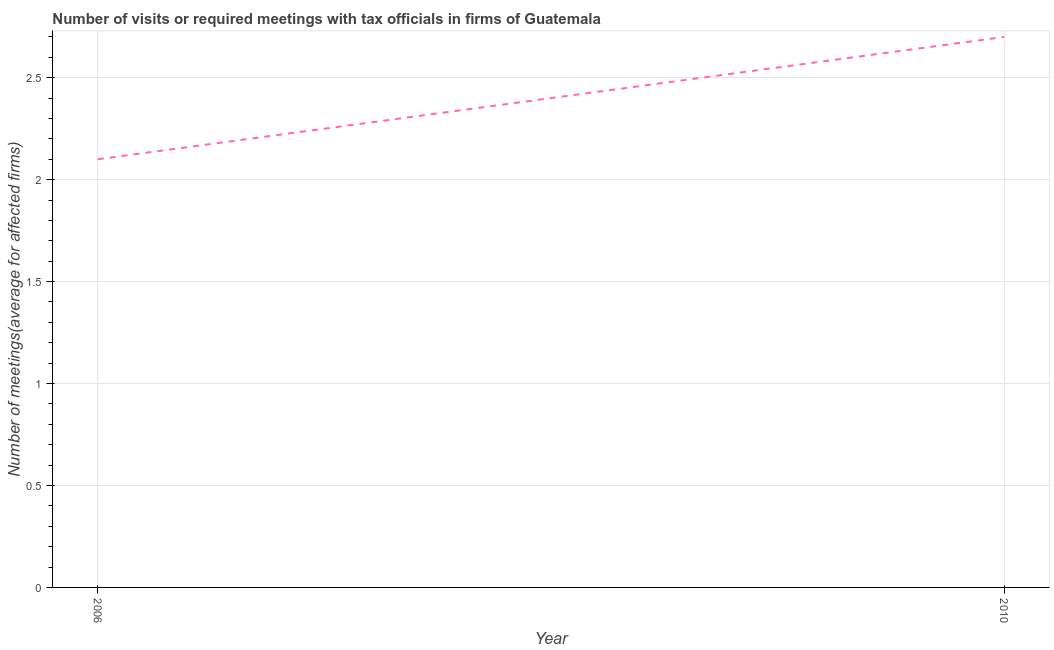Across all years, what is the maximum number of required meetings with tax officials?
Your answer should be very brief. 2.7. Across all years, what is the minimum number of required meetings with tax officials?
Offer a very short reply. 2.1. In which year was the number of required meetings with tax officials minimum?
Provide a succinct answer. 2006. What is the sum of the number of required meetings with tax officials?
Offer a terse response. 4.8. What is the difference between the number of required meetings with tax officials in 2006 and 2010?
Keep it short and to the point. -0.6. What is the average number of required meetings with tax officials per year?
Make the answer very short. 2.4. What is the median number of required meetings with tax officials?
Provide a short and direct response. 2.4. In how many years, is the number of required meetings with tax officials greater than 0.9 ?
Make the answer very short. 2. Do a majority of the years between 2010 and 2006 (inclusive) have number of required meetings with tax officials greater than 2 ?
Your answer should be very brief. No. What is the ratio of the number of required meetings with tax officials in 2006 to that in 2010?
Ensure brevity in your answer.  0.78. Is the number of required meetings with tax officials in 2006 less than that in 2010?
Provide a short and direct response. Yes. How many lines are there?
Keep it short and to the point. 1. How many years are there in the graph?
Ensure brevity in your answer.  2. Are the values on the major ticks of Y-axis written in scientific E-notation?
Offer a terse response. No. What is the title of the graph?
Ensure brevity in your answer.  Number of visits or required meetings with tax officials in firms of Guatemala. What is the label or title of the Y-axis?
Provide a short and direct response. Number of meetings(average for affected firms). What is the Number of meetings(average for affected firms) of 2006?
Make the answer very short. 2.1. What is the Number of meetings(average for affected firms) of 2010?
Give a very brief answer. 2.7. What is the difference between the Number of meetings(average for affected firms) in 2006 and 2010?
Provide a succinct answer. -0.6. What is the ratio of the Number of meetings(average for affected firms) in 2006 to that in 2010?
Your response must be concise. 0.78. 